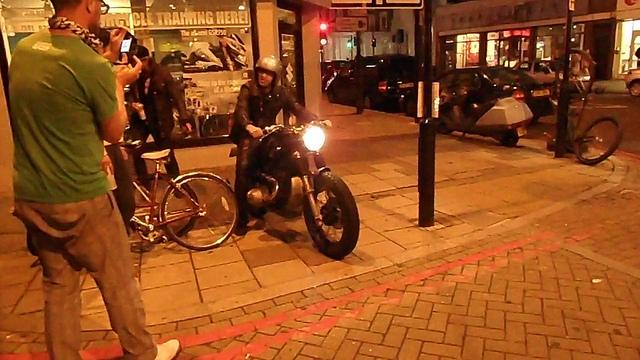What is aimed at the man on the motorcycle?

Choices:
A) camera
B) antique blunderbuss
C) paintball
D) ruler camera 